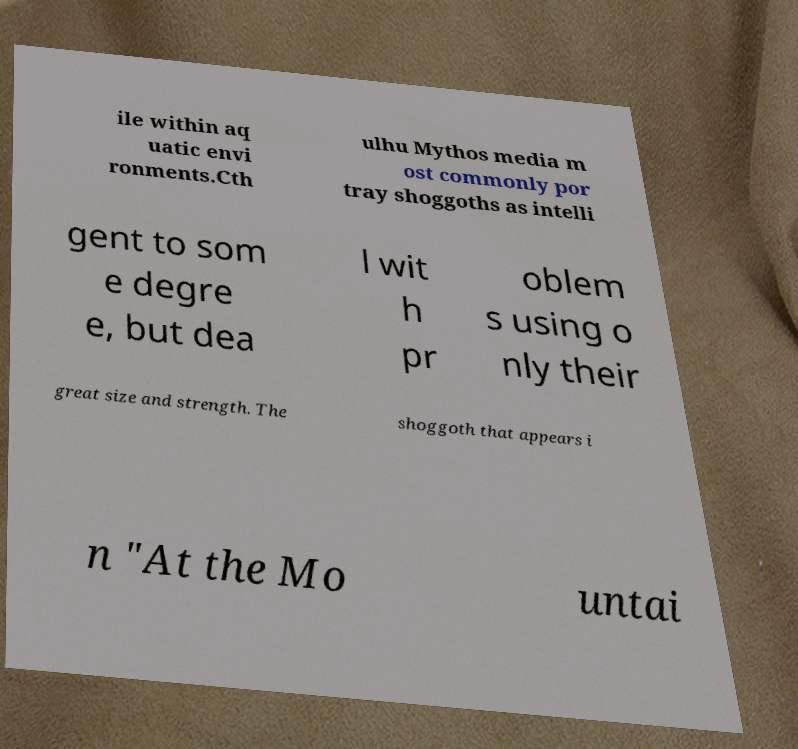Could you extract and type out the text from this image? ile within aq uatic envi ronments.Cth ulhu Mythos media m ost commonly por tray shoggoths as intelli gent to som e degre e, but dea l wit h pr oblem s using o nly their great size and strength. The shoggoth that appears i n "At the Mo untai 